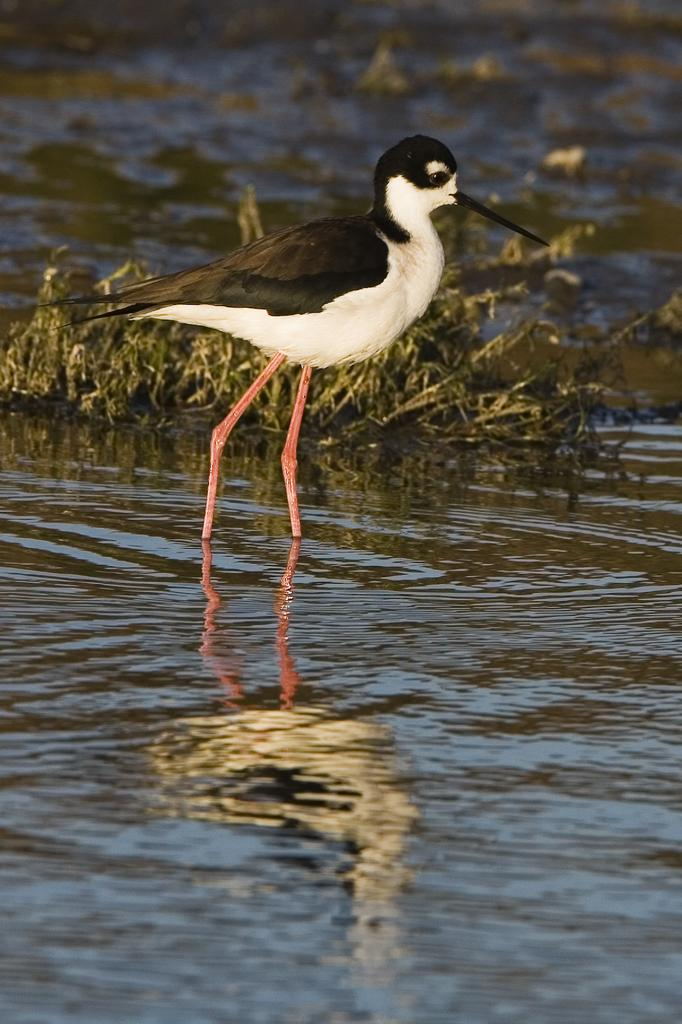What type of animal can be seen in the water in the image? There is a bird in the water in the image. What else can be seen in the image besides the bird? There are plants in the image. What degree does the bird have in the image? The bird does not have a degree in the image, as degrees are not applicable to animals. 